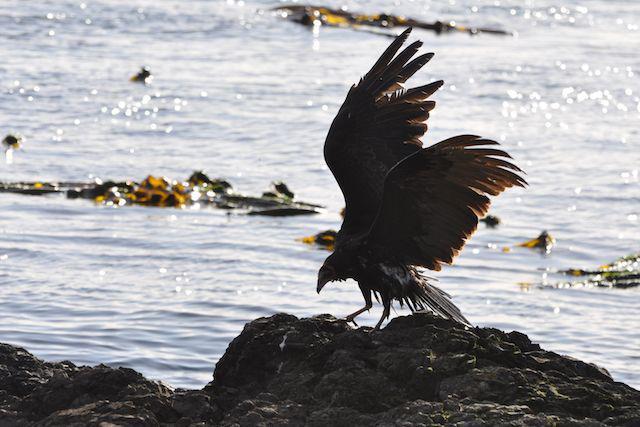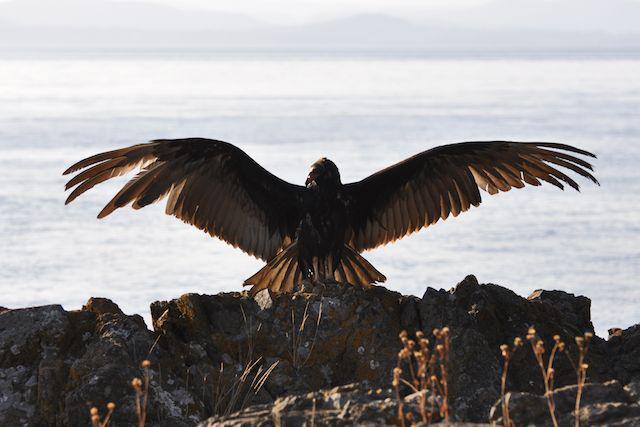The first image is the image on the left, the second image is the image on the right. For the images shown, is this caption "An image shows one leftward swimming bird with wings that are not spread." true? Answer yes or no. No. The first image is the image on the left, the second image is the image on the right. Given the left and right images, does the statement "There are two birds, both in water." hold true? Answer yes or no. No. 